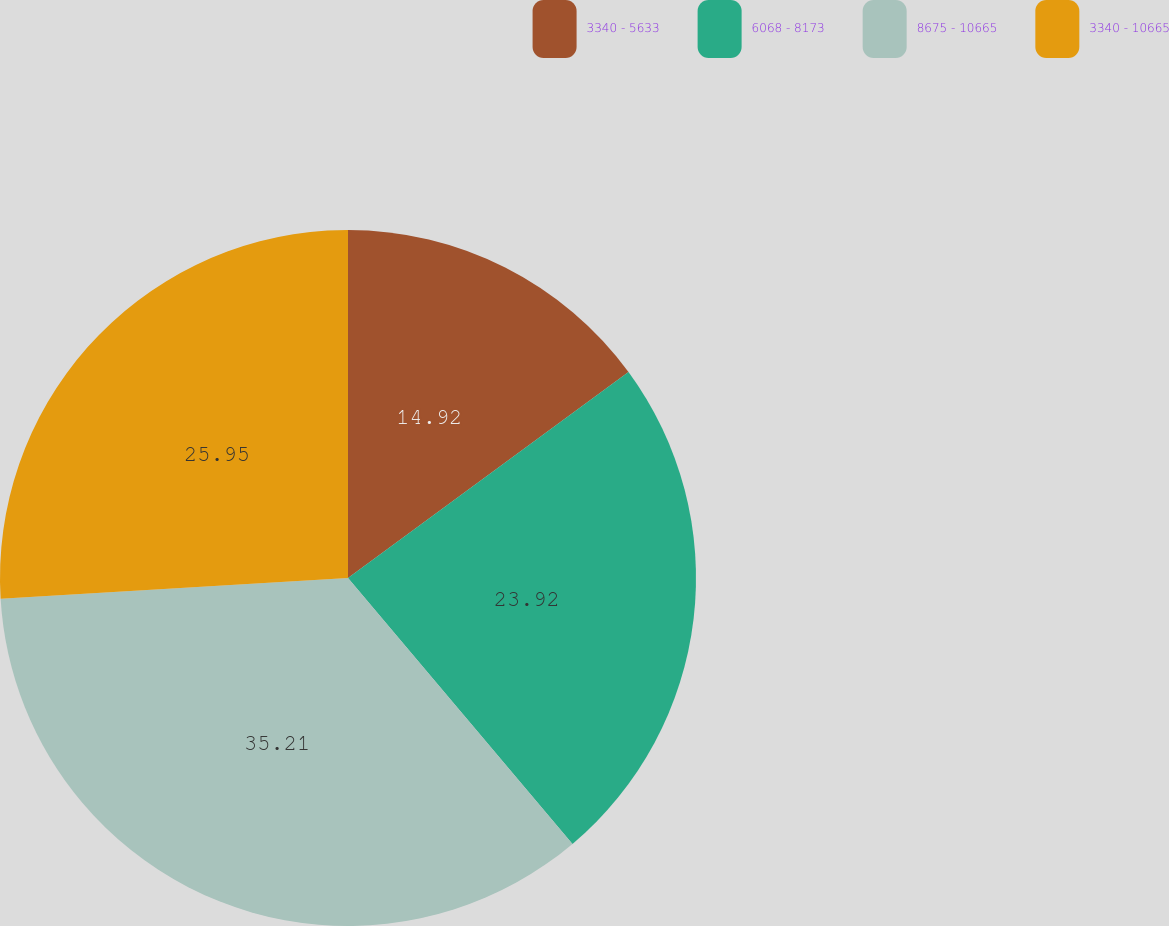Convert chart to OTSL. <chart><loc_0><loc_0><loc_500><loc_500><pie_chart><fcel>3340 - 5633<fcel>6068 - 8173<fcel>8675 - 10665<fcel>3340 - 10665<nl><fcel>14.92%<fcel>23.92%<fcel>35.21%<fcel>25.95%<nl></chart> 